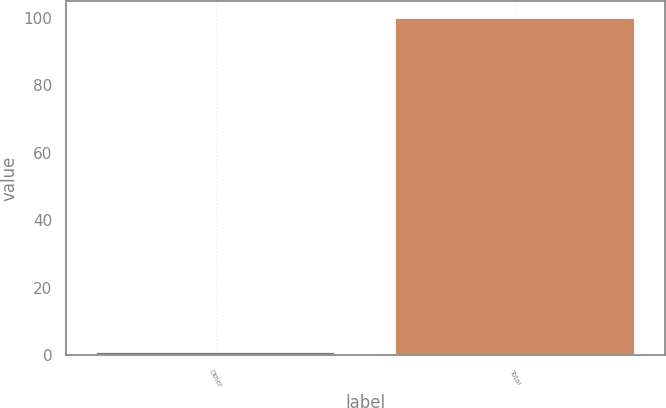Convert chart. <chart><loc_0><loc_0><loc_500><loc_500><bar_chart><fcel>Other<fcel>Total<nl><fcel>1<fcel>100<nl></chart> 